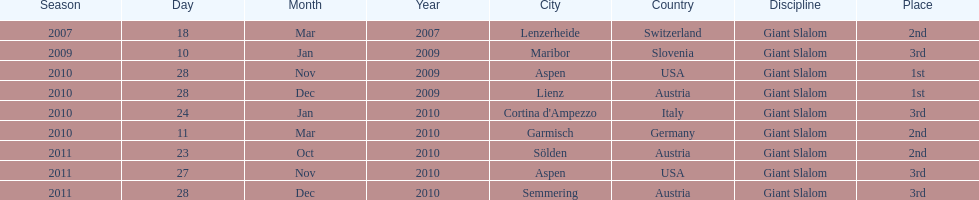What is the only location in the us? Aspen. 